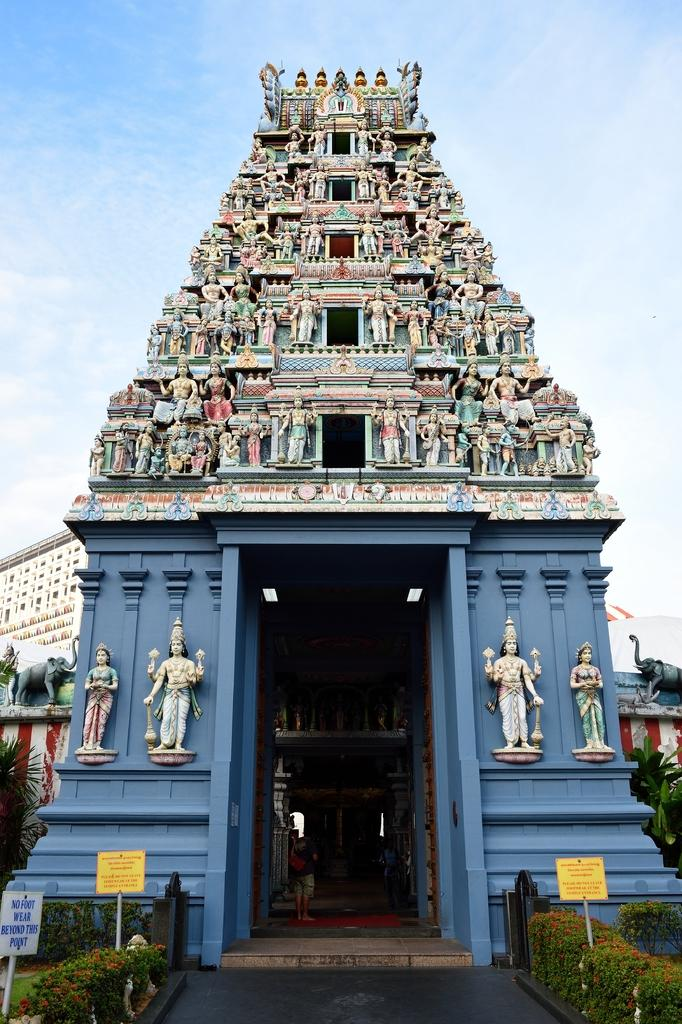What type of structure is visible in the image? There is a temple in the image. Are there any people present in the image? Yes, there are people in the image. What else can be seen inside the temple? There are idols in the image. What type of vegetation is present in the image? There are plants and grass in the image. What is the condition of the sky in the image? The sky is cloudy in the image. What other objects can be seen in the image? There are boards and other objects in the image. Can you see any fish swimming in the image? No, there are no fish present in the image. Are there any skateboards visible in the image? No, there are no skateboards present in the image. 